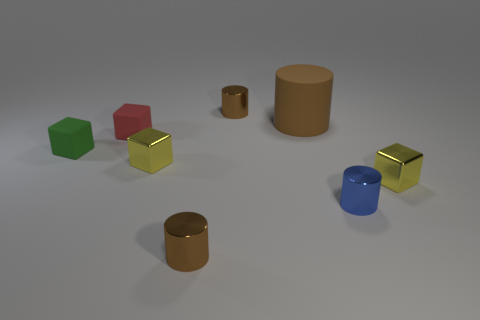Subtract all small blue metal cylinders. How many cylinders are left? 3 Subtract all blue cylinders. How many cylinders are left? 3 Add 1 brown rubber things. How many objects exist? 9 Subtract all yellow cylinders. How many blue blocks are left? 0 Subtract all shiny blocks. Subtract all tiny metal things. How many objects are left? 1 Add 6 small brown objects. How many small brown objects are left? 8 Add 5 small blue matte cylinders. How many small blue matte cylinders exist? 5 Subtract 0 brown spheres. How many objects are left? 8 Subtract 3 cylinders. How many cylinders are left? 1 Subtract all gray blocks. Subtract all red balls. How many blocks are left? 4 